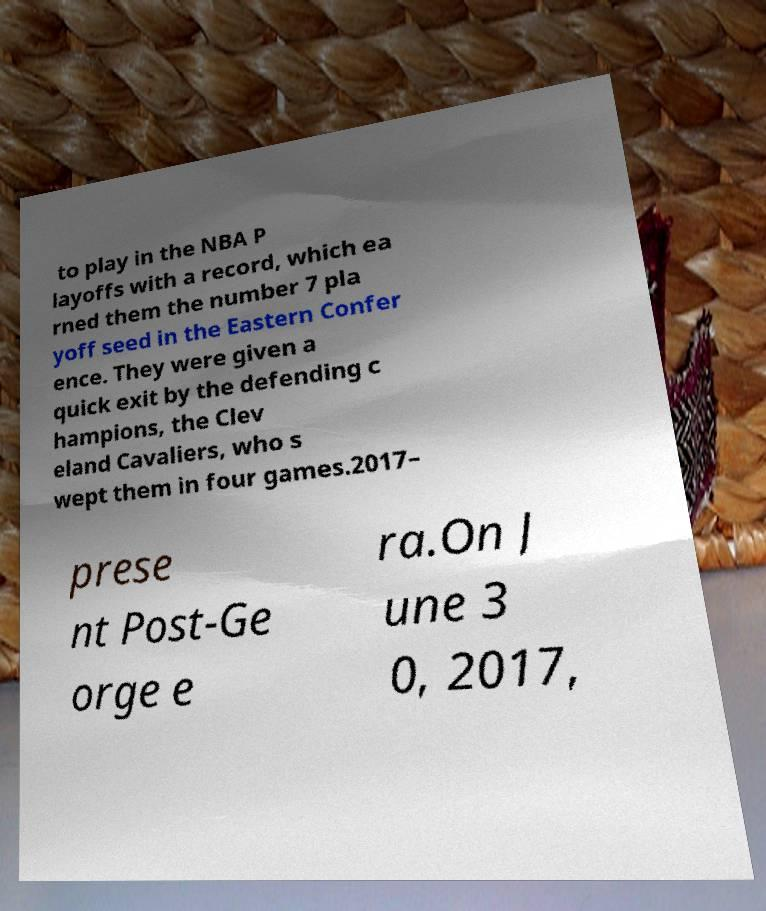There's text embedded in this image that I need extracted. Can you transcribe it verbatim? to play in the NBA P layoffs with a record, which ea rned them the number 7 pla yoff seed in the Eastern Confer ence. They were given a quick exit by the defending c hampions, the Clev eland Cavaliers, who s wept them in four games.2017– prese nt Post-Ge orge e ra.On J une 3 0, 2017, 